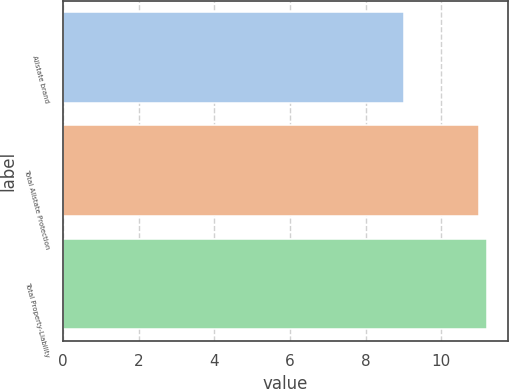Convert chart to OTSL. <chart><loc_0><loc_0><loc_500><loc_500><bar_chart><fcel>Allstate brand<fcel>Total Allstate Protection<fcel>Total Property-Liability<nl><fcel>9<fcel>11<fcel>11.2<nl></chart> 